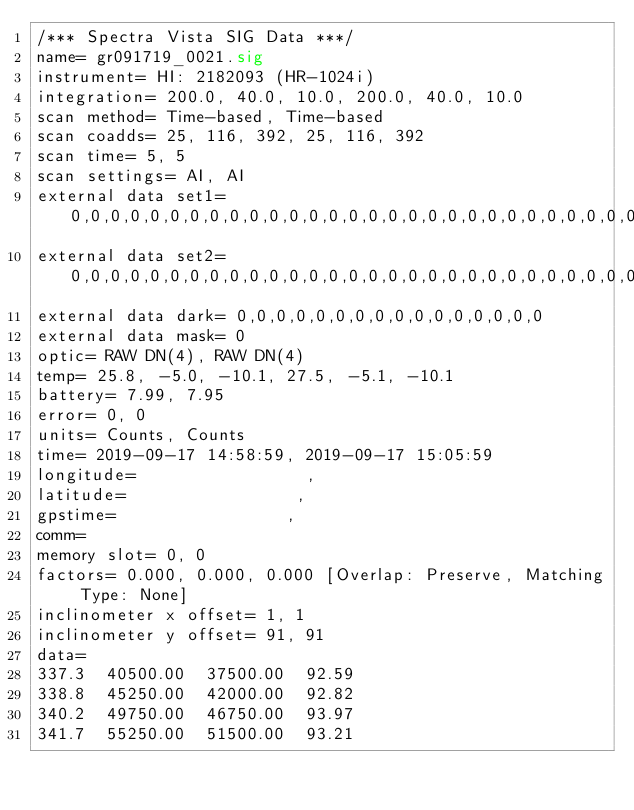Convert code to text. <code><loc_0><loc_0><loc_500><loc_500><_SML_>/*** Spectra Vista SIG Data ***/
name= gr091719_0021.sig
instrument= HI: 2182093 (HR-1024i)
integration= 200.0, 40.0, 10.0, 200.0, 40.0, 10.0
scan method= Time-based, Time-based
scan coadds= 25, 116, 392, 25, 116, 392
scan time= 5, 5
scan settings= AI, AI
external data set1= 0,0,0,0,0,0,0,0,0,0,0,0,0,0,0,0,0,0,0,0,0,0,0,0,0,0,0,0,0,0,0,0
external data set2= 0,0,0,0,0,0,0,0,0,0,0,0,0,0,0,0,0,0,0,0,0,0,0,0,0,0,0,0,0,0,0,0
external data dark= 0,0,0,0,0,0,0,0,0,0,0,0,0,0,0,0
external data mask= 0
optic= RAW DN(4), RAW DN(4)
temp= 25.8, -5.0, -10.1, 27.5, -5.1, -10.1
battery= 7.99, 7.95
error= 0, 0
units= Counts, Counts
time= 2019-09-17 14:58:59, 2019-09-17 15:05:59
longitude=                 ,                 
latitude=                 ,                 
gpstime=                 ,                 
comm= 
memory slot= 0, 0
factors= 0.000, 0.000, 0.000 [Overlap: Preserve, Matching Type: None]
inclinometer x offset= 1, 1
inclinometer y offset= 91, 91
data= 
337.3  40500.00  37500.00  92.59
338.8  45250.00  42000.00  92.82
340.2  49750.00  46750.00  93.97
341.7  55250.00  51500.00  93.21</code> 